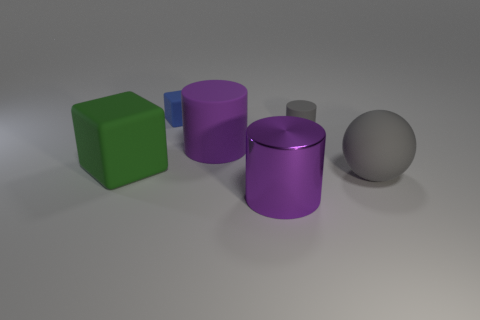Add 3 small green metallic cylinders. How many objects exist? 9 Subtract all small cylinders. How many cylinders are left? 2 Subtract all cyan blocks. How many purple cylinders are left? 2 Subtract 0 brown cylinders. How many objects are left? 6 Subtract all spheres. How many objects are left? 5 Subtract all yellow blocks. Subtract all blue cylinders. How many blocks are left? 2 Subtract all big cylinders. Subtract all cyan rubber cubes. How many objects are left? 4 Add 4 big gray objects. How many big gray objects are left? 5 Add 3 large purple rubber things. How many large purple rubber things exist? 4 